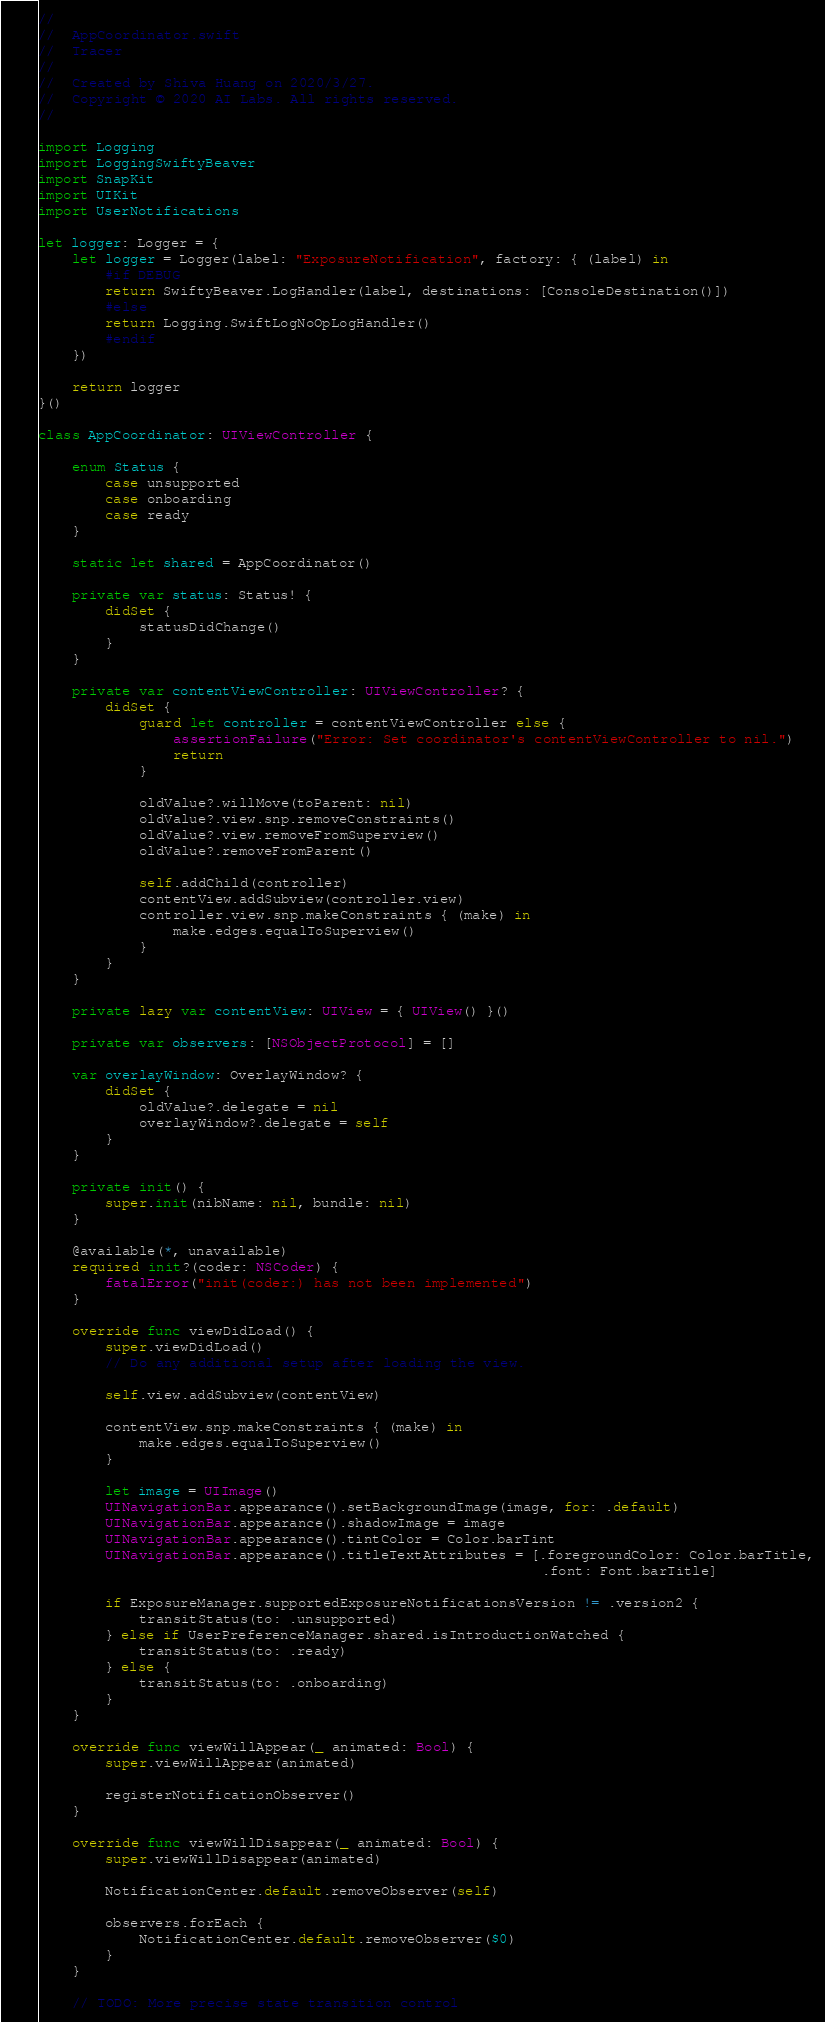<code> <loc_0><loc_0><loc_500><loc_500><_Swift_>//
//  AppCoordinator.swift
//  Tracer
//
//  Created by Shiva Huang on 2020/3/27.
//  Copyright © 2020 AI Labs. All rights reserved.
//

import Logging
import LoggingSwiftyBeaver
import SnapKit
import UIKit
import UserNotifications

let logger: Logger = {
    let logger = Logger(label: "ExposureNotification", factory: { (label) in
        #if DEBUG
        return SwiftyBeaver.LogHandler(label, destinations: [ConsoleDestination()])
        #else
        return Logging.SwiftLogNoOpLogHandler()
        #endif
    })

    return logger
}()

class AppCoordinator: UIViewController {
    
    enum Status {
        case unsupported
        case onboarding
        case ready
    }

    static let shared = AppCoordinator()
    
    private var status: Status! {
        didSet {
            statusDidChange()
        }
    }

    private var contentViewController: UIViewController? {
        didSet {
            guard let controller = contentViewController else {
                assertionFailure("Error: Set coordinator's contentViewController to nil.")
                return
            }
            
            oldValue?.willMove(toParent: nil)
            oldValue?.view.snp.removeConstraints()
            oldValue?.view.removeFromSuperview()
            oldValue?.removeFromParent()
            
            self.addChild(controller)
            contentView.addSubview(controller.view)
            controller.view.snp.makeConstraints { (make) in
                make.edges.equalToSuperview()
            }
        }
    }
    
    private lazy var contentView: UIView = { UIView() }()

    private var observers: [NSObjectProtocol] = []

    var overlayWindow: OverlayWindow? {
        didSet {
            oldValue?.delegate = nil
            overlayWindow?.delegate = self
        }
    }

    private init() {
        super.init(nibName: nil, bundle: nil)
    }

    @available(*, unavailable)
    required init?(coder: NSCoder) {
        fatalError("init(coder:) has not been implemented")
    }

    override func viewDidLoad() {
        super.viewDidLoad()
        // Do any additional setup after loading the view.
        
        self.view.addSubview(contentView)
        
        contentView.snp.makeConstraints { (make) in
            make.edges.equalToSuperview()
        }
        
        let image = UIImage()
        UINavigationBar.appearance().setBackgroundImage(image, for: .default)
        UINavigationBar.appearance().shadowImage = image
        UINavigationBar.appearance().tintColor = Color.barTint
        UINavigationBar.appearance().titleTextAttributes = [.foregroundColor: Color.barTitle,
                                                            .font: Font.barTitle]

        if ExposureManager.supportedExposureNotificationsVersion != .version2 {
            transitStatus(to: .unsupported)
        } else if UserPreferenceManager.shared.isIntroductionWatched {
            transitStatus(to: .ready)
        } else {
            transitStatus(to: .onboarding)
        }
    }
    
    override func viewWillAppear(_ animated: Bool) {
        super.viewWillAppear(animated)
        
        registerNotificationObserver()
    }
    
    override func viewWillDisappear(_ animated: Bool) {
        super.viewWillDisappear(animated)
        
        NotificationCenter.default.removeObserver(self)

        observers.forEach {
            NotificationCenter.default.removeObserver($0)
        }
    }
    
    // TODO: More precise state transition control</code> 